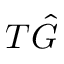Convert formula to latex. <formula><loc_0><loc_0><loc_500><loc_500>T \hat { G }</formula> 